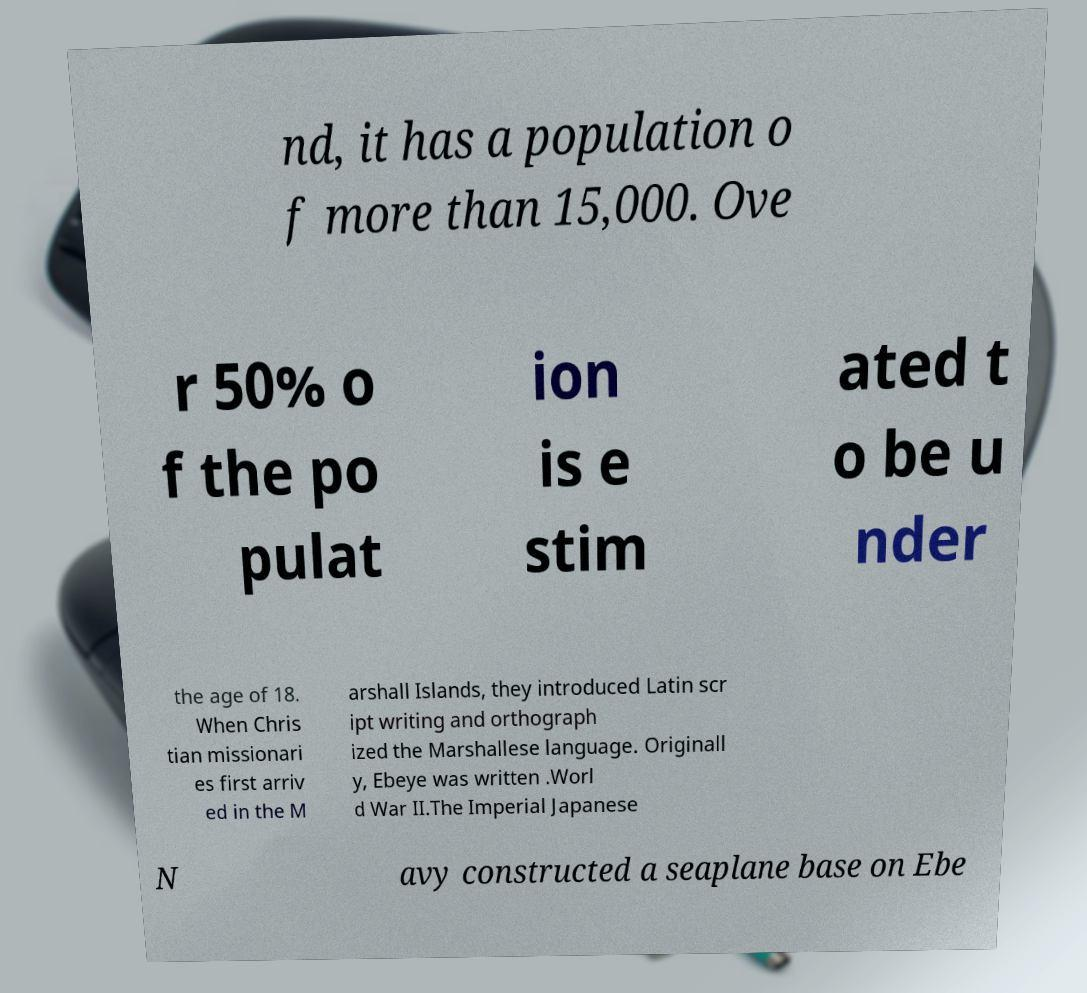I need the written content from this picture converted into text. Can you do that? nd, it has a population o f more than 15,000. Ove r 50% o f the po pulat ion is e stim ated t o be u nder the age of 18. When Chris tian missionari es first arriv ed in the M arshall Islands, they introduced Latin scr ipt writing and orthograph ized the Marshallese language. Originall y, Ebeye was written .Worl d War II.The Imperial Japanese N avy constructed a seaplane base on Ebe 